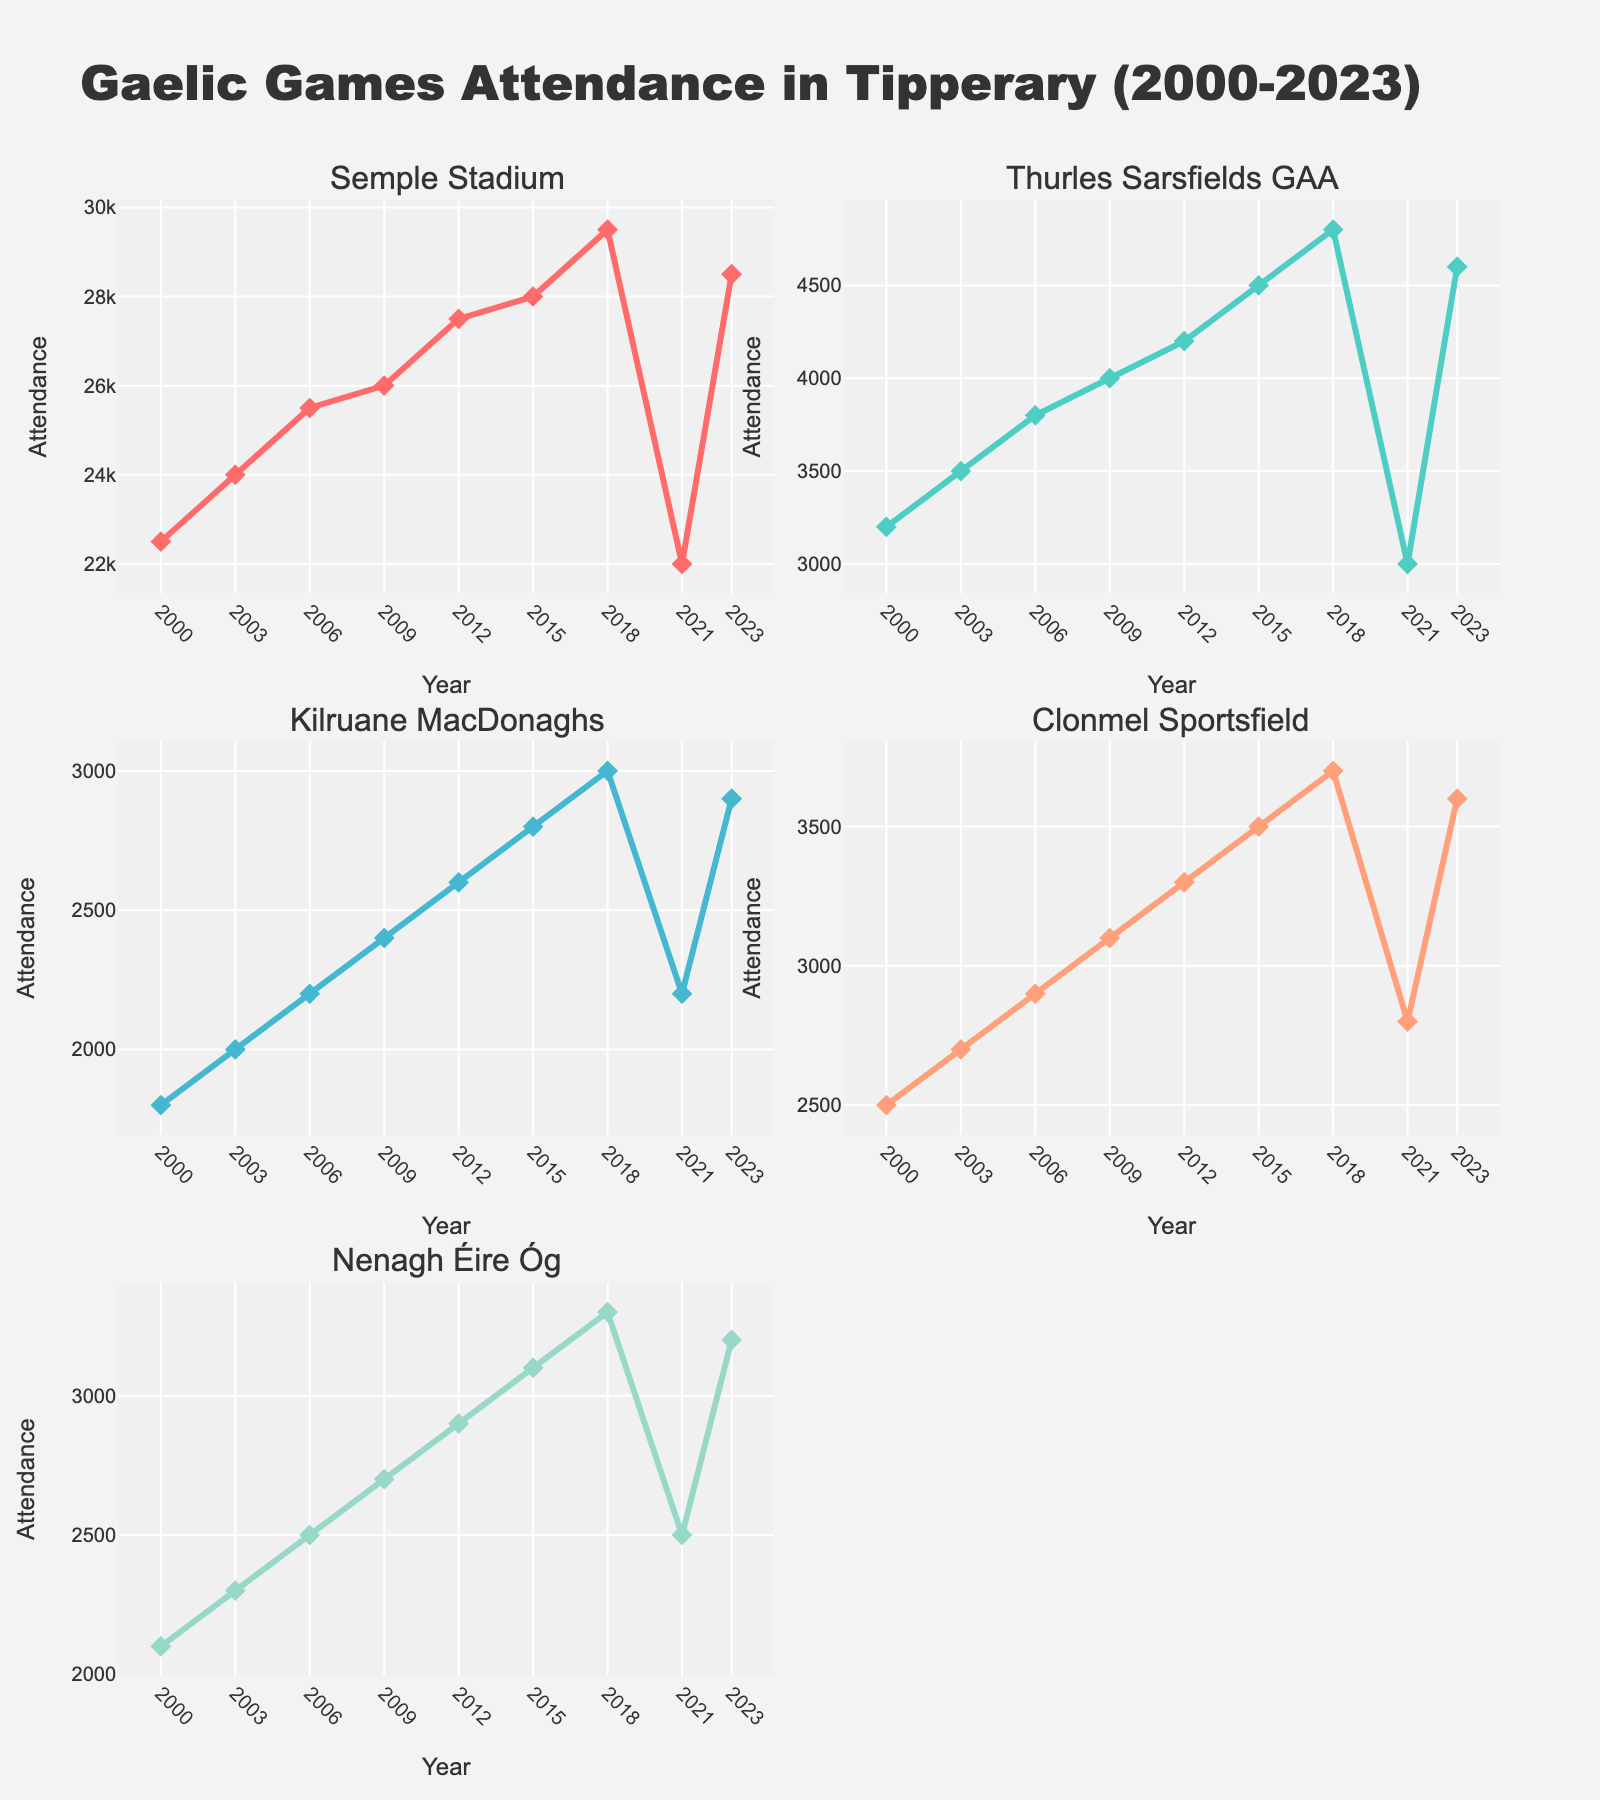What's the title of the figure? The title of the figure is displayed prominently at the top of the plot. It reads "Gaelic Games Attendance in Tipperary (2000-2023)."
Answer: Gaelic Games Attendance in Tipperary (2000-2023) Which venue had the highest attendance in 2023? By looking at the line chart for each venue, we find that Semple Stadium had the highest attendance in 2023, which shows a value of 28,500.
Answer: Semple Stadium How did the attendance at Thurles Sarsfields GAA change from 2000 to 2023? From the subplots, we see that the attendance at Thurles Sarsfields GAA started at 3,200 in 2000 and increased to 4,600 in 2023. The overall trend is upward.
Answer: Increase Which year saw a peak in attendance at Semple Stadium? By examining the line chart for Semple Stadium, we observe that the peak attendance occurred in 2018 with a value of 29,500.
Answer: 2018 Compare the trends in attendance between Clonmel Sportsfield and Kilruane MacDonaghs. From the subplots, we notice that both venues show similar upward trends in attendance over the years. Clonmel Sportsfield and Kilruane MacDonaghs both increased, though Clonmel had slightly higher values throughout.
Answer: Both increased, Clonmel slightly higher What was the attendance difference between the highest and lowest years for Nenagh Éire Óg? The highest attendance year for Nenagh Éire Óg is 2018 with 3,300, and the lowest is 2000 with 2,100. The difference is 3,300 - 2,100 = 1,200.
Answer: 1,200 How did the overall attendance trend change for all venues between 2000 and 2023? By observing the line charts for all venues, it is clear that the general trend for all venues is an increase in attendance over the given period, with a slight dip around 2021.
Answer: Increase, slight dip in 2021 What is the average attendance at Kilruane MacDonaghs over the years plotted on the chart? The attendance values at Kilruane MacDonaghs are: 1800, 2000, 2200, 2400, 2600, 2800, 3000, 2200, 2900. Adding these gives 21900, and there are 9 data points. So, the average is 21900/9 ≈ 2,433.33.
Answer: 2,433.33 Which venue had the least variation in attendance figures over the years? Based on the line charts, Thurles Sarsfields GAA shows a consistent upward trend without large fluctuations, indicating the least variation in attendance figures.
Answer: Thurles Sarsfields GAA In 2021, which venue had a notable drop in attendance compared to previous years? By examining the line charts, we see that Semple Stadium had a notable drop in attendance in 2021 compared to previous years, dropping to 22,000 from 29,500 in 2018.
Answer: Semple Stadium 